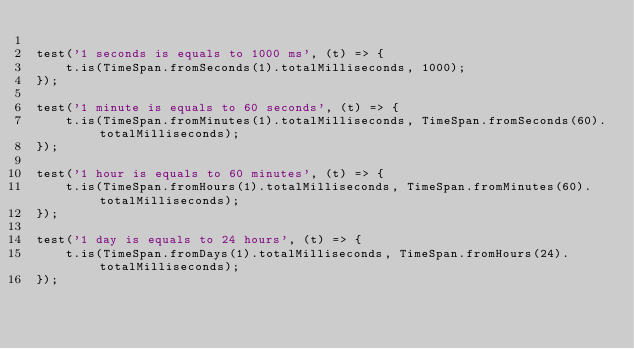Convert code to text. <code><loc_0><loc_0><loc_500><loc_500><_JavaScript_>
test('1 seconds is equals to 1000 ms', (t) => {
    t.is(TimeSpan.fromSeconds(1).totalMilliseconds, 1000);
});

test('1 minute is equals to 60 seconds', (t) => {
    t.is(TimeSpan.fromMinutes(1).totalMilliseconds, TimeSpan.fromSeconds(60).totalMilliseconds);
});

test('1 hour is equals to 60 minutes', (t) => {
    t.is(TimeSpan.fromHours(1).totalMilliseconds, TimeSpan.fromMinutes(60).totalMilliseconds);
});

test('1 day is equals to 24 hours', (t) => {
    t.is(TimeSpan.fromDays(1).totalMilliseconds, TimeSpan.fromHours(24).totalMilliseconds);
});
</code> 